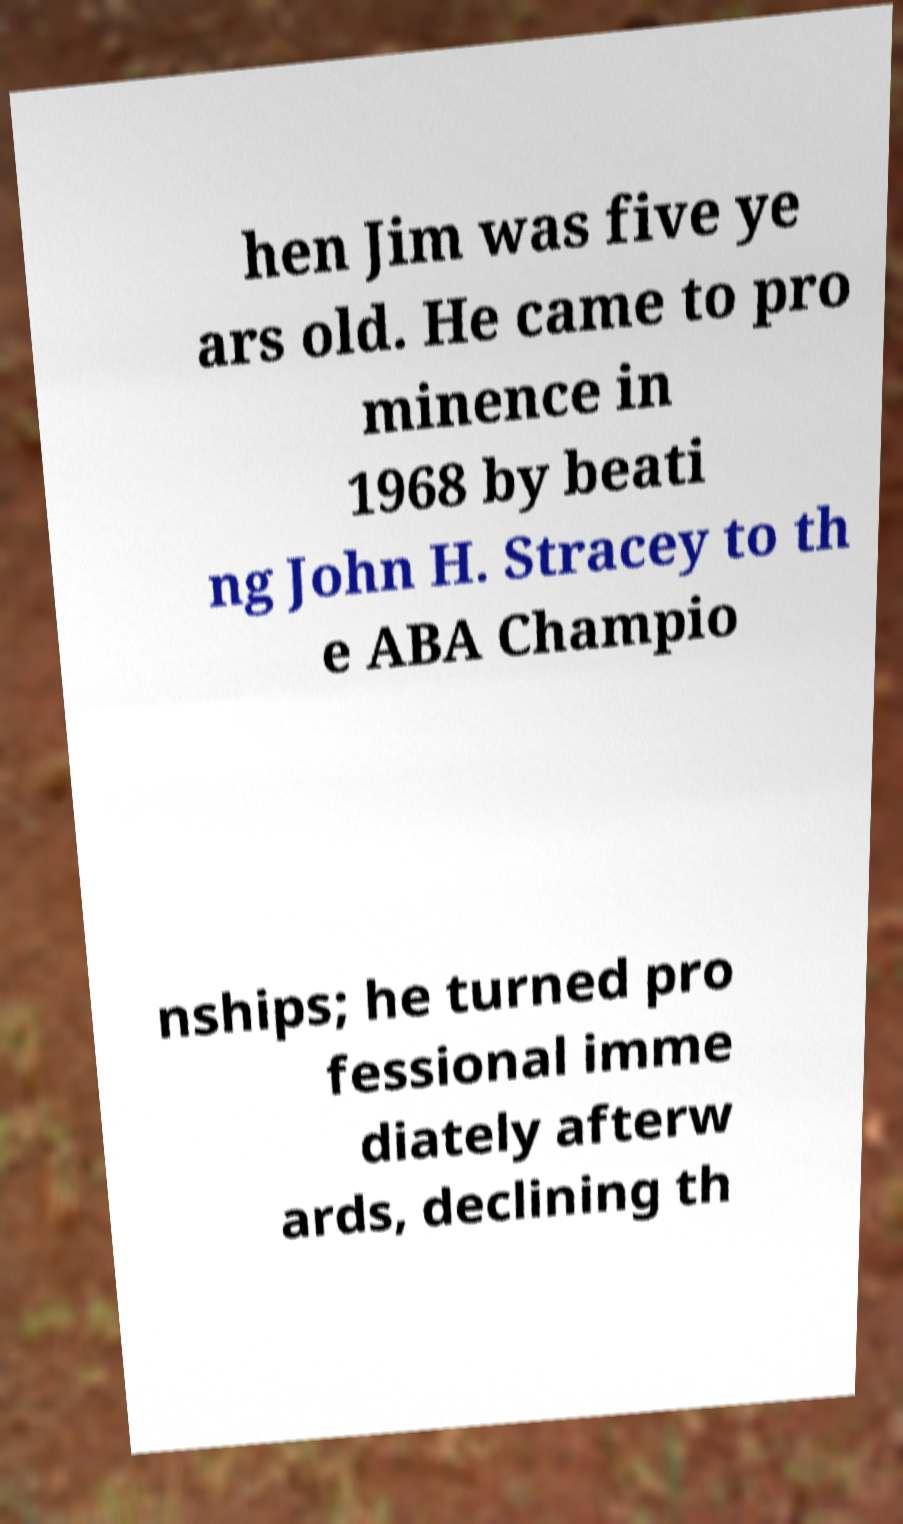Can you read and provide the text displayed in the image?This photo seems to have some interesting text. Can you extract and type it out for me? hen Jim was five ye ars old. He came to pro minence in 1968 by beati ng John H. Stracey to th e ABA Champio nships; he turned pro fessional imme diately afterw ards, declining th 